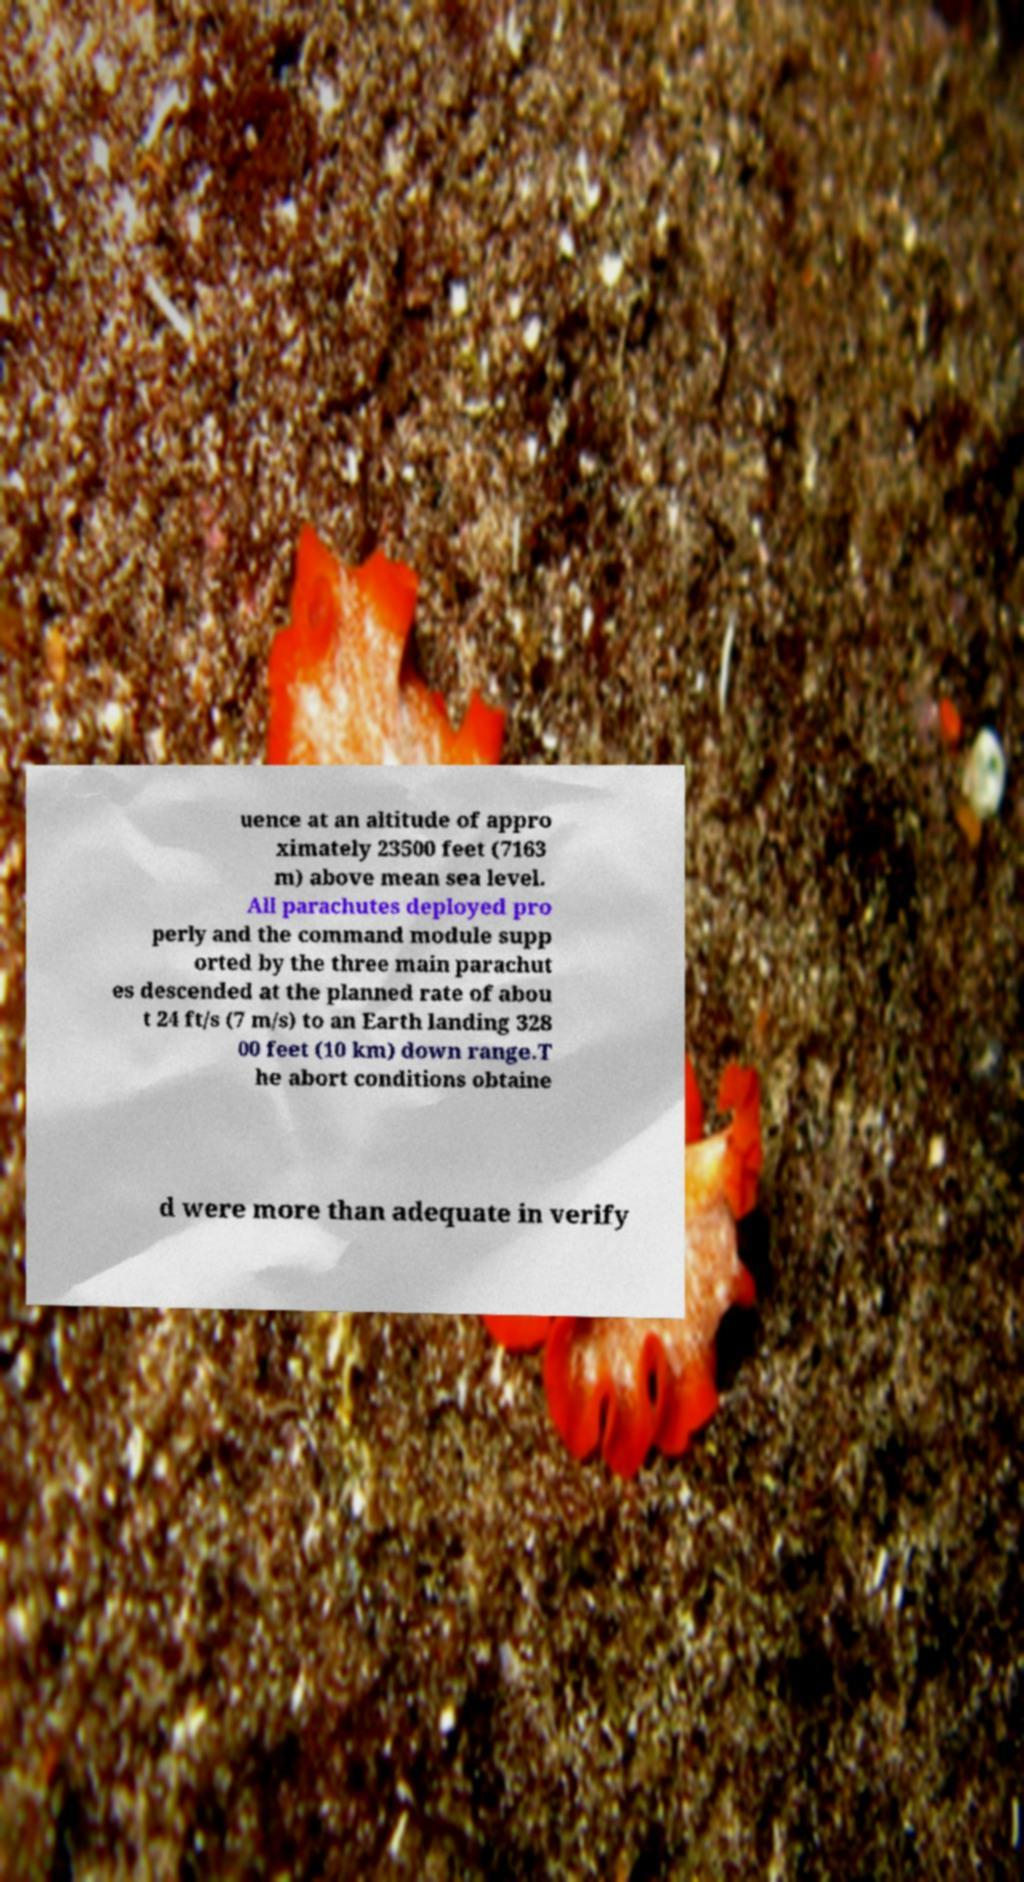Please identify and transcribe the text found in this image. uence at an altitude of appro ximately 23500 feet (7163 m) above mean sea level. All parachutes deployed pro perly and the command module supp orted by the three main parachut es descended at the planned rate of abou t 24 ft/s (7 m/s) to an Earth landing 328 00 feet (10 km) down range.T he abort conditions obtaine d were more than adequate in verify 